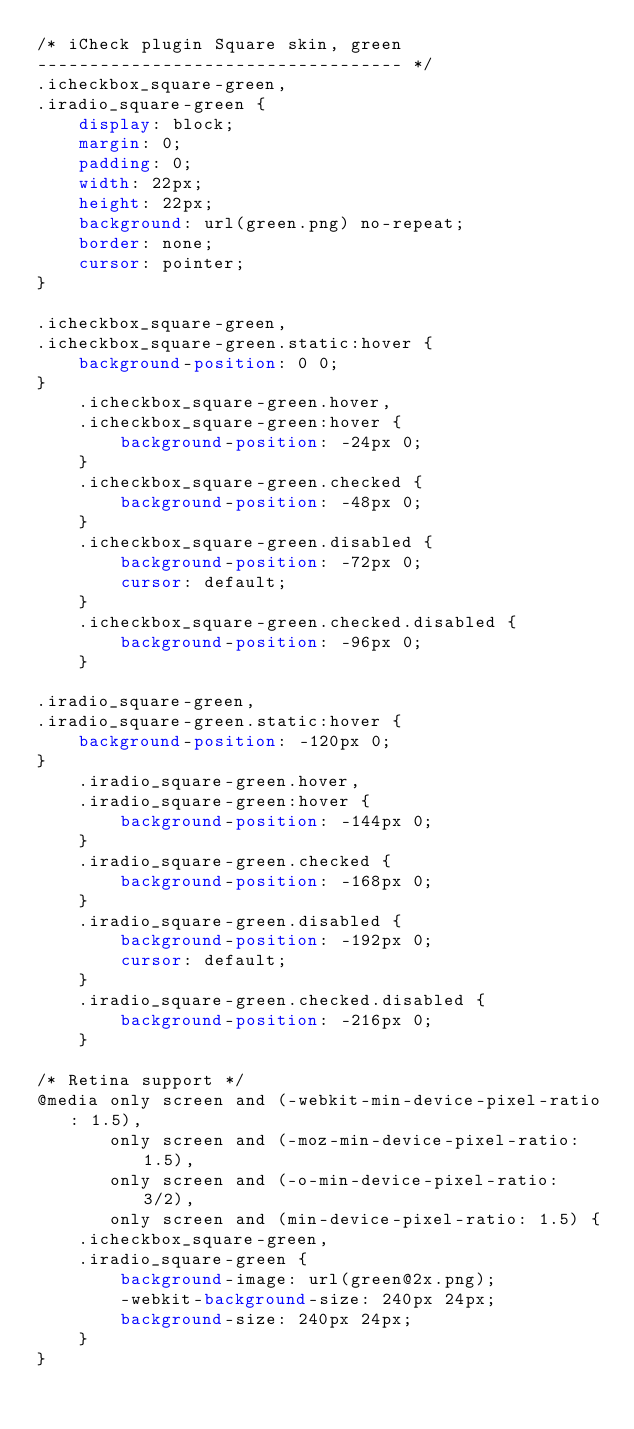<code> <loc_0><loc_0><loc_500><loc_500><_CSS_>/* iCheck plugin Square skin, green
----------------------------------- */
.icheckbox_square-green,
.iradio_square-green {
    display: block;
    margin: 0;
    padding: 0;
    width: 22px;
    height: 22px;
    background: url(green.png) no-repeat;
    border: none;
    cursor: pointer;
}

.icheckbox_square-green,
.icheckbox_square-green.static:hover {
    background-position: 0 0;
}
    .icheckbox_square-green.hover,
    .icheckbox_square-green:hover {
        background-position: -24px 0;
    }
    .icheckbox_square-green.checked {
        background-position: -48px 0;
    }
    .icheckbox_square-green.disabled {
        background-position: -72px 0;
        cursor: default;
    }
    .icheckbox_square-green.checked.disabled {
        background-position: -96px 0;
    }

.iradio_square-green,
.iradio_square-green.static:hover {
    background-position: -120px 0;
}
    .iradio_square-green.hover,
    .iradio_square-green:hover {
        background-position: -144px 0;
    }
    .iradio_square-green.checked {
        background-position: -168px 0;
    }
    .iradio_square-green.disabled {
        background-position: -192px 0;
        cursor: default;
    }
    .iradio_square-green.checked.disabled {
        background-position: -216px 0;
    }

/* Retina support */
@media only screen and (-webkit-min-device-pixel-ratio: 1.5),
       only screen and (-moz-min-device-pixel-ratio: 1.5),
       only screen and (-o-min-device-pixel-ratio: 3/2),
       only screen and (min-device-pixel-ratio: 1.5) {
    .icheckbox_square-green,
    .iradio_square-green {
        background-image: url(green@2x.png);
        -webkit-background-size: 240px 24px;
        background-size: 240px 24px;
    }
}</code> 